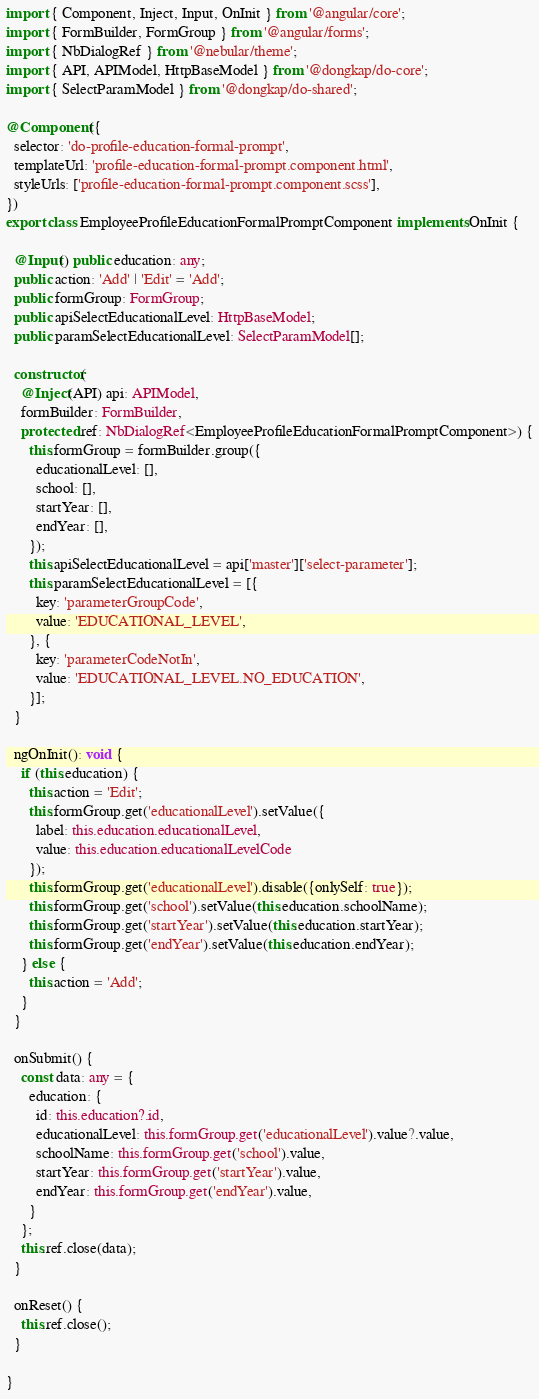<code> <loc_0><loc_0><loc_500><loc_500><_TypeScript_>import { Component, Inject, Input, OnInit } from '@angular/core';
import { FormBuilder, FormGroup } from '@angular/forms';
import { NbDialogRef } from '@nebular/theme';
import { API, APIModel, HttpBaseModel } from '@dongkap/do-core';
import { SelectParamModel } from '@dongkap/do-shared';

@Component({
  selector: 'do-profile-education-formal-prompt',
  templateUrl: 'profile-education-formal-prompt.component.html',
  styleUrls: ['profile-education-formal-prompt.component.scss'],
})
export class EmployeeProfileEducationFormalPromptComponent implements OnInit {

  @Input() public education: any;
  public action: 'Add' | 'Edit' = 'Add';
  public formGroup: FormGroup;
  public apiSelectEducationalLevel: HttpBaseModel;
  public paramSelectEducationalLevel: SelectParamModel[];

  constructor(
    @Inject(API) api: APIModel,
    formBuilder: FormBuilder,
    protected ref: NbDialogRef<EmployeeProfileEducationFormalPromptComponent>) {
      this.formGroup = formBuilder.group({
        educationalLevel: [],
        school: [],
        startYear: [],
        endYear: [],
      });
      this.apiSelectEducationalLevel = api['master']['select-parameter'];
      this.paramSelectEducationalLevel = [{
        key: 'parameterGroupCode',
        value: 'EDUCATIONAL_LEVEL',
      }, {
        key: 'parameterCodeNotIn',
        value: 'EDUCATIONAL_LEVEL.NO_EDUCATION',
      }];
  }

  ngOnInit(): void {
    if (this.education) {
      this.action = 'Edit';
      this.formGroup.get('educationalLevel').setValue({
        label: this.education.educationalLevel,
        value: this.education.educationalLevelCode
      });
      this.formGroup.get('educationalLevel').disable({onlySelf: true});
      this.formGroup.get('school').setValue(this.education.schoolName);
      this.formGroup.get('startYear').setValue(this.education.startYear);
      this.formGroup.get('endYear').setValue(this.education.endYear);
    } else {
      this.action = 'Add';
    }
  }

  onSubmit() {
    const data: any = {
      education: {
        id: this.education?.id,
        educationalLevel: this.formGroup.get('educationalLevel').value?.value,
        schoolName: this.formGroup.get('school').value,
        startYear: this.formGroup.get('startYear').value,
        endYear: this.formGroup.get('endYear').value,
      }
    };
    this.ref.close(data);
  }

  onReset() {
    this.ref.close();
  }

}
</code> 